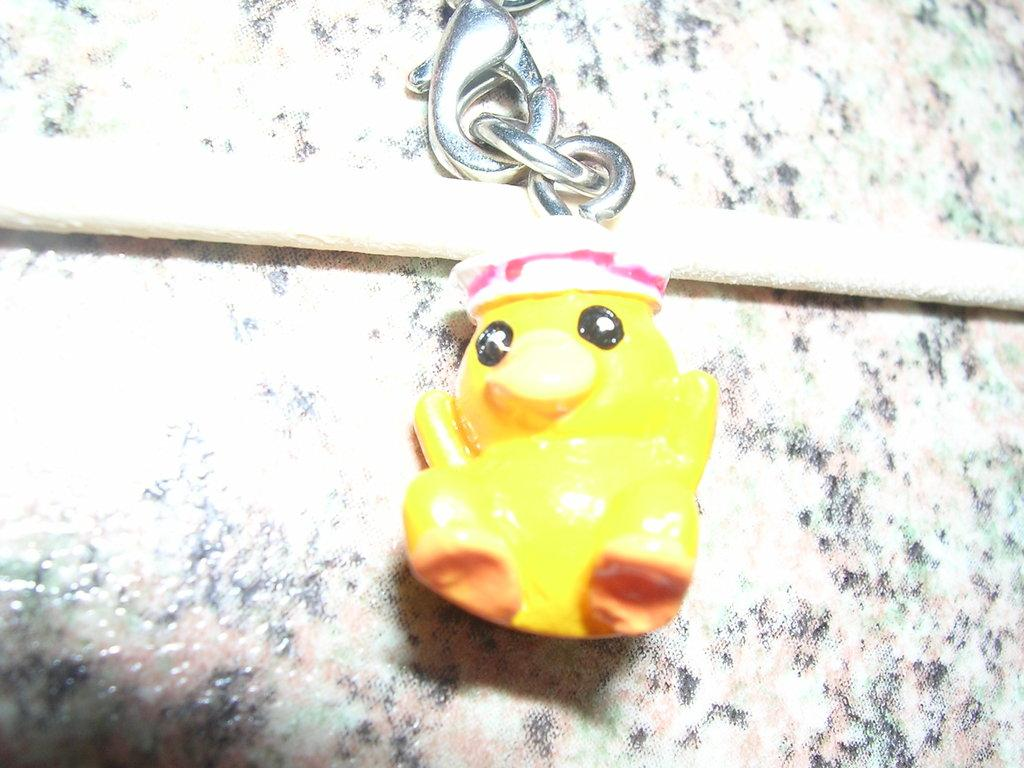What object can be seen in the image that is typically used for play? There is a toy in the image. How is the toy connected to another object? The toy is attached to a keychain. What is located at the bottom of the image? There is a marble and rope at the bottom of the image. What type of guitar can be seen in the image? There is no guitar present in the image. 